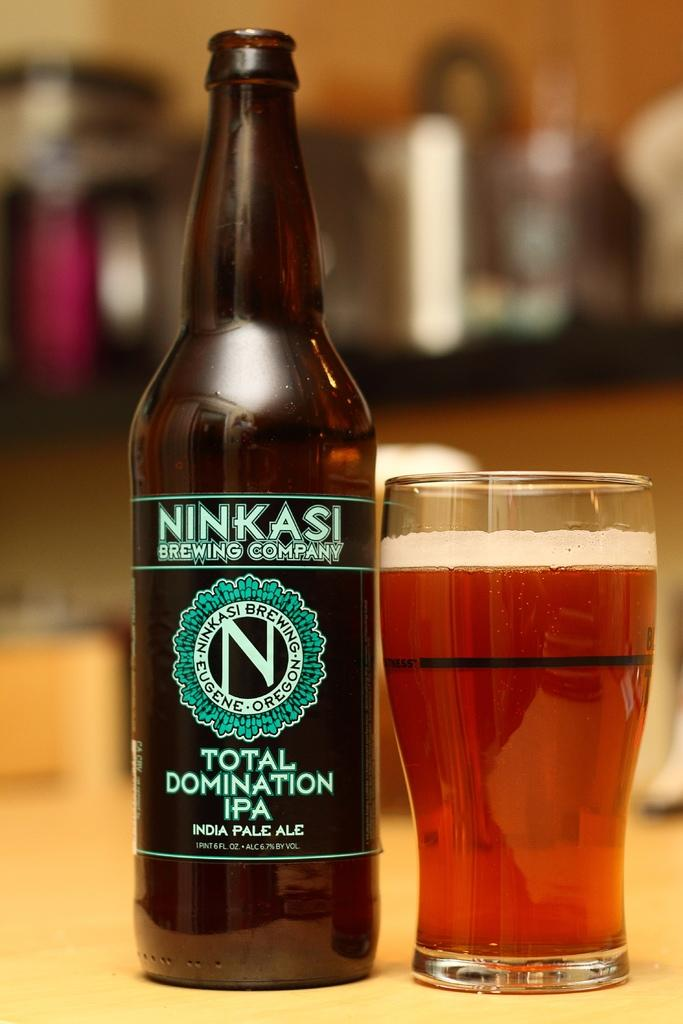<image>
Offer a succinct explanation of the picture presented. An empty bottle of Inida Pale Ale next to a glass that is full. 